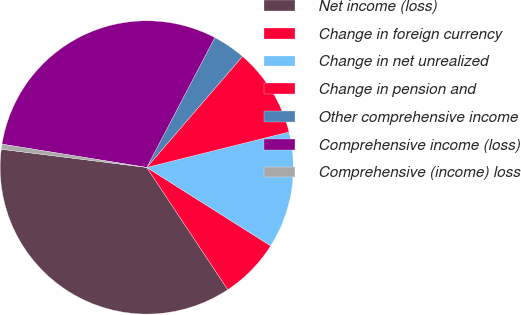Convert chart. <chart><loc_0><loc_0><loc_500><loc_500><pie_chart><fcel>Net income (loss)<fcel>Change in foreign currency<fcel>Change in net unrealized<fcel>Change in pension and<fcel>Other comprehensive income<fcel>Comprehensive income (loss)<fcel>Comprehensive (income) loss<nl><fcel>36.29%<fcel>6.71%<fcel>12.86%<fcel>9.79%<fcel>3.64%<fcel>30.14%<fcel>0.56%<nl></chart> 